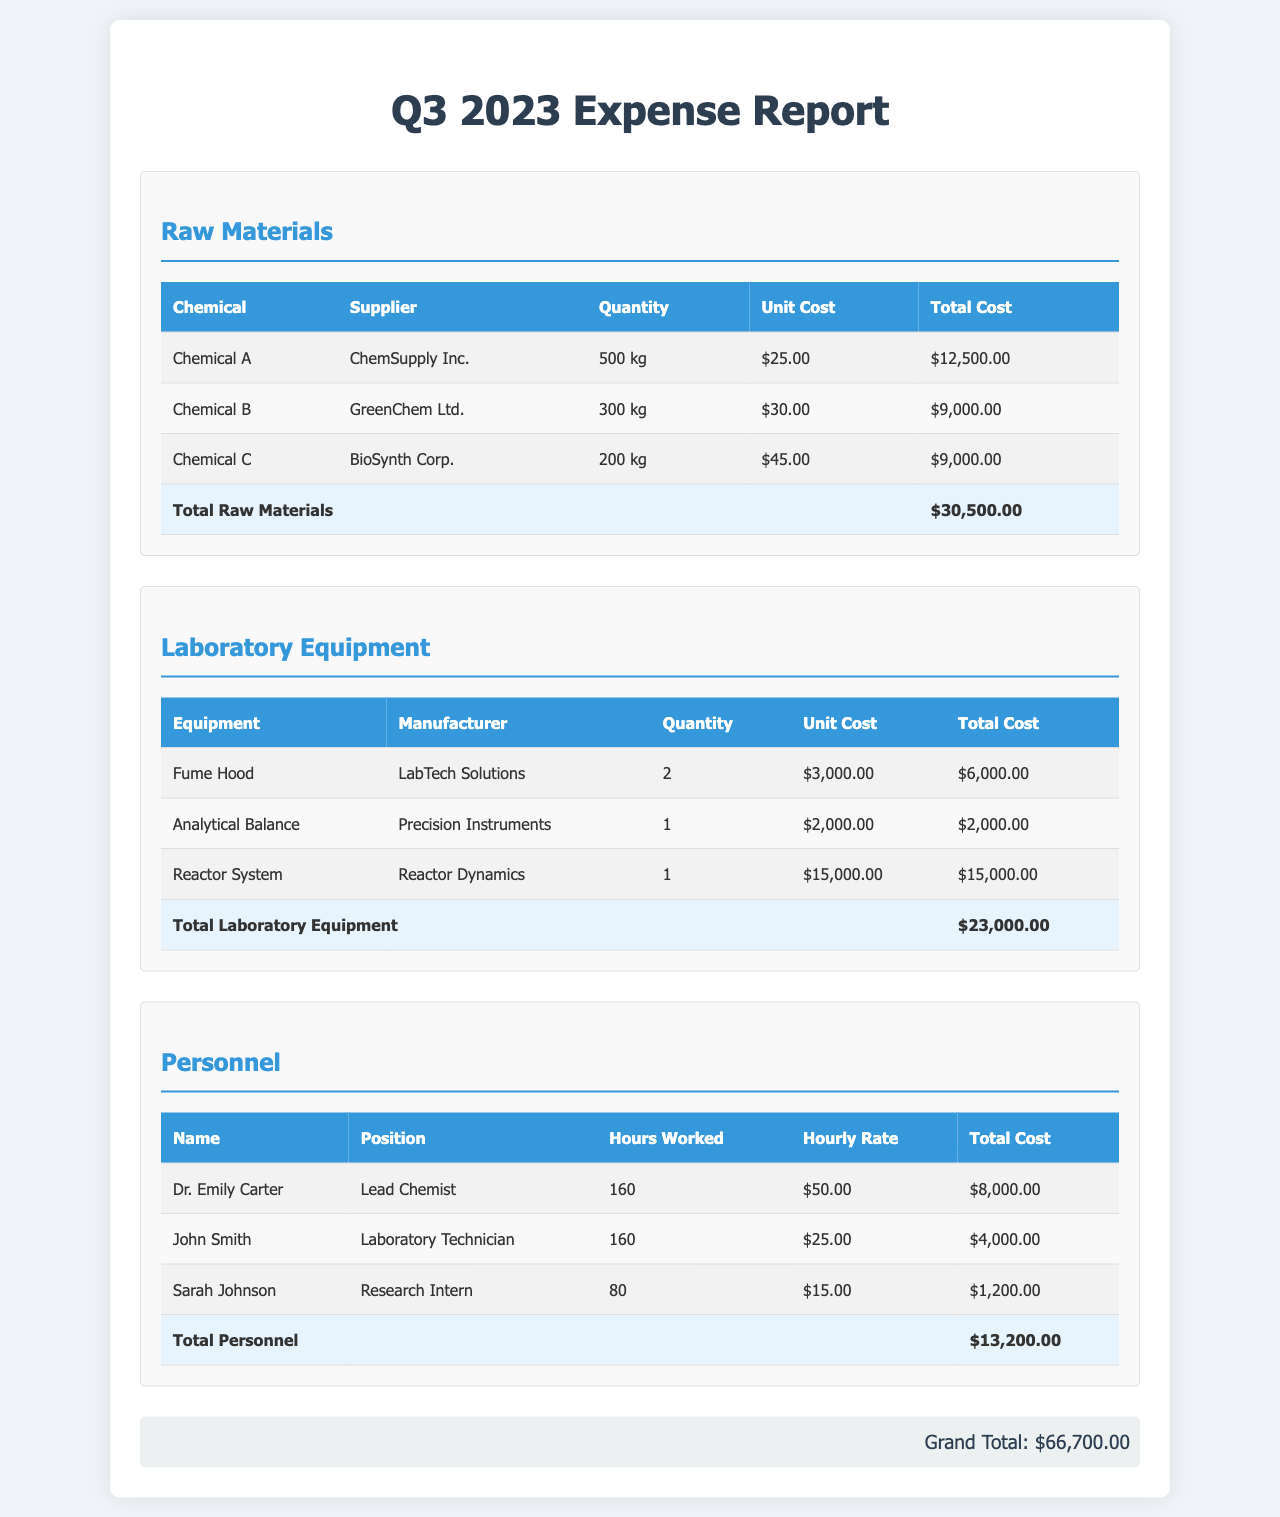What was the total cost of raw materials? The total cost of raw materials is provided in the table as the last entry, which sums up the individual costs of the chemicals.
Answer: $30,500.00 How many kg of Chemical B were purchased? The document specifies the quantity of Chemical B in the raw materials section of the expense report.
Answer: 300 kg Who is the manufacturer of the Reactor System? The document lists the manufacturers for each piece of laboratory equipment, including the Reactor System.
Answer: Reactor Dynamics What is the total personnel cost? The expense report calculates the total personnel cost at the end of the personnel section by summing up all individual totals.
Answer: $13,200.00 How many Fume Hoods were purchased? The quantity of Fume Hoods purchased is stated in the table for laboratory equipment.
Answer: 2 What is the hourly rate for Sarah Johnson? The document shows the hourly rates for each personnel listed, including Sarah Johnson.
Answer: $15.00 Who supplied Chemical C? The supplier for Chemical C is provided in the raw materials section of the expense report.
Answer: BioSynth Corp What is the grand total of all expenses? The grand total is given at the bottom of the document, which represents the total expenses across all sections.
Answer: $66,700.00 